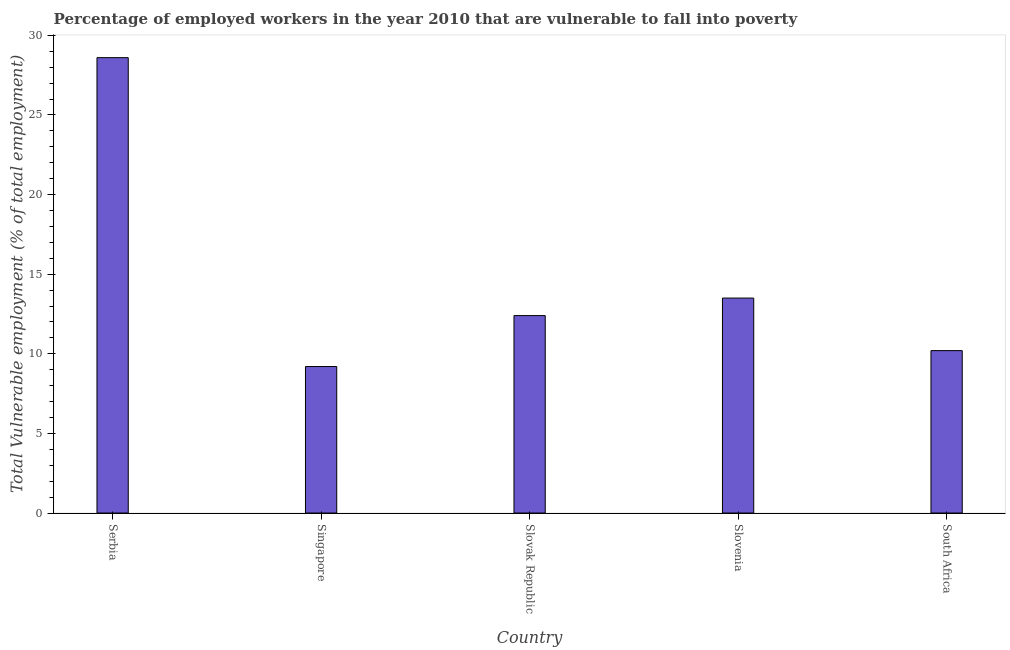Does the graph contain any zero values?
Your answer should be very brief. No. What is the title of the graph?
Offer a terse response. Percentage of employed workers in the year 2010 that are vulnerable to fall into poverty. What is the label or title of the X-axis?
Give a very brief answer. Country. What is the label or title of the Y-axis?
Give a very brief answer. Total Vulnerable employment (% of total employment). What is the total vulnerable employment in Slovak Republic?
Your response must be concise. 12.4. Across all countries, what is the maximum total vulnerable employment?
Make the answer very short. 28.6. Across all countries, what is the minimum total vulnerable employment?
Give a very brief answer. 9.2. In which country was the total vulnerable employment maximum?
Your response must be concise. Serbia. In which country was the total vulnerable employment minimum?
Ensure brevity in your answer.  Singapore. What is the sum of the total vulnerable employment?
Ensure brevity in your answer.  73.9. What is the average total vulnerable employment per country?
Provide a succinct answer. 14.78. What is the median total vulnerable employment?
Offer a terse response. 12.4. What is the ratio of the total vulnerable employment in Singapore to that in Slovak Republic?
Provide a succinct answer. 0.74. What is the difference between the highest and the second highest total vulnerable employment?
Ensure brevity in your answer.  15.1. Are all the bars in the graph horizontal?
Make the answer very short. No. How many countries are there in the graph?
Offer a terse response. 5. What is the difference between two consecutive major ticks on the Y-axis?
Provide a short and direct response. 5. What is the Total Vulnerable employment (% of total employment) of Serbia?
Ensure brevity in your answer.  28.6. What is the Total Vulnerable employment (% of total employment) of Singapore?
Your answer should be very brief. 9.2. What is the Total Vulnerable employment (% of total employment) of Slovak Republic?
Give a very brief answer. 12.4. What is the Total Vulnerable employment (% of total employment) of South Africa?
Keep it short and to the point. 10.2. What is the difference between the Total Vulnerable employment (% of total employment) in Serbia and Singapore?
Keep it short and to the point. 19.4. What is the difference between the Total Vulnerable employment (% of total employment) in Serbia and Slovenia?
Provide a short and direct response. 15.1. What is the difference between the Total Vulnerable employment (% of total employment) in Serbia and South Africa?
Ensure brevity in your answer.  18.4. What is the ratio of the Total Vulnerable employment (% of total employment) in Serbia to that in Singapore?
Your response must be concise. 3.11. What is the ratio of the Total Vulnerable employment (% of total employment) in Serbia to that in Slovak Republic?
Make the answer very short. 2.31. What is the ratio of the Total Vulnerable employment (% of total employment) in Serbia to that in Slovenia?
Keep it short and to the point. 2.12. What is the ratio of the Total Vulnerable employment (% of total employment) in Serbia to that in South Africa?
Provide a short and direct response. 2.8. What is the ratio of the Total Vulnerable employment (% of total employment) in Singapore to that in Slovak Republic?
Ensure brevity in your answer.  0.74. What is the ratio of the Total Vulnerable employment (% of total employment) in Singapore to that in Slovenia?
Offer a terse response. 0.68. What is the ratio of the Total Vulnerable employment (% of total employment) in Singapore to that in South Africa?
Ensure brevity in your answer.  0.9. What is the ratio of the Total Vulnerable employment (% of total employment) in Slovak Republic to that in Slovenia?
Your answer should be compact. 0.92. What is the ratio of the Total Vulnerable employment (% of total employment) in Slovak Republic to that in South Africa?
Your answer should be very brief. 1.22. What is the ratio of the Total Vulnerable employment (% of total employment) in Slovenia to that in South Africa?
Give a very brief answer. 1.32. 